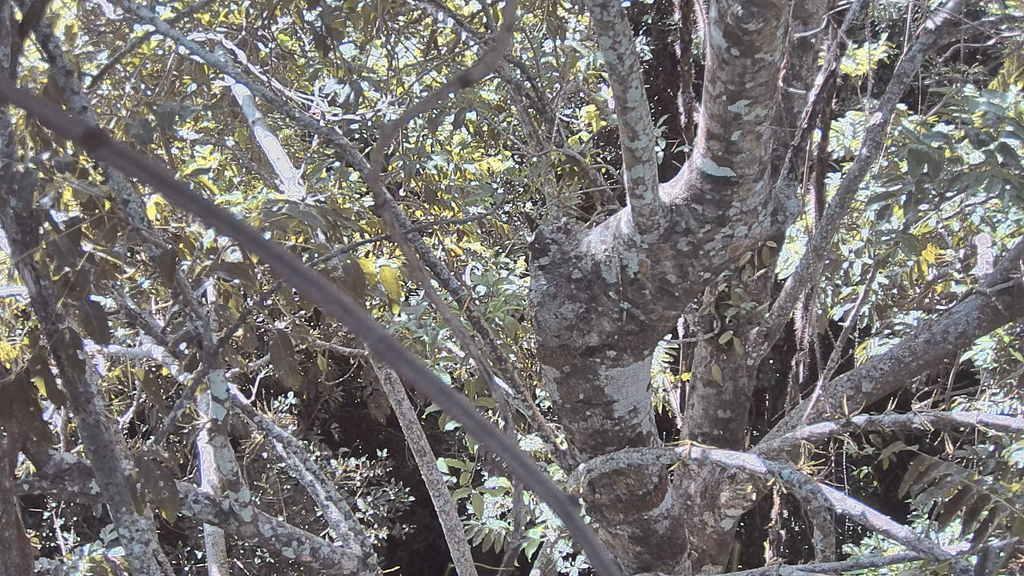Please provide a concise description of this image. In this picture I can see the trees. On the left I can see the tree branches. In the back I can see many leaves. 